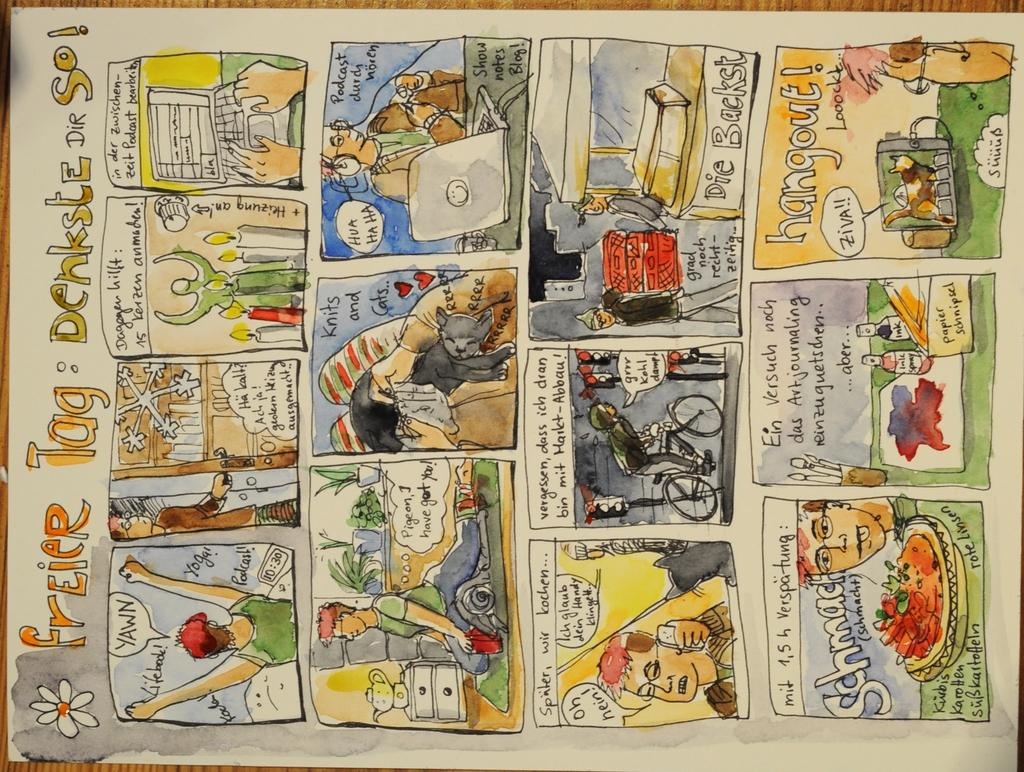<image>
Describe the image concisely. A comic is titled Freier Tag and includes a full page comic. 